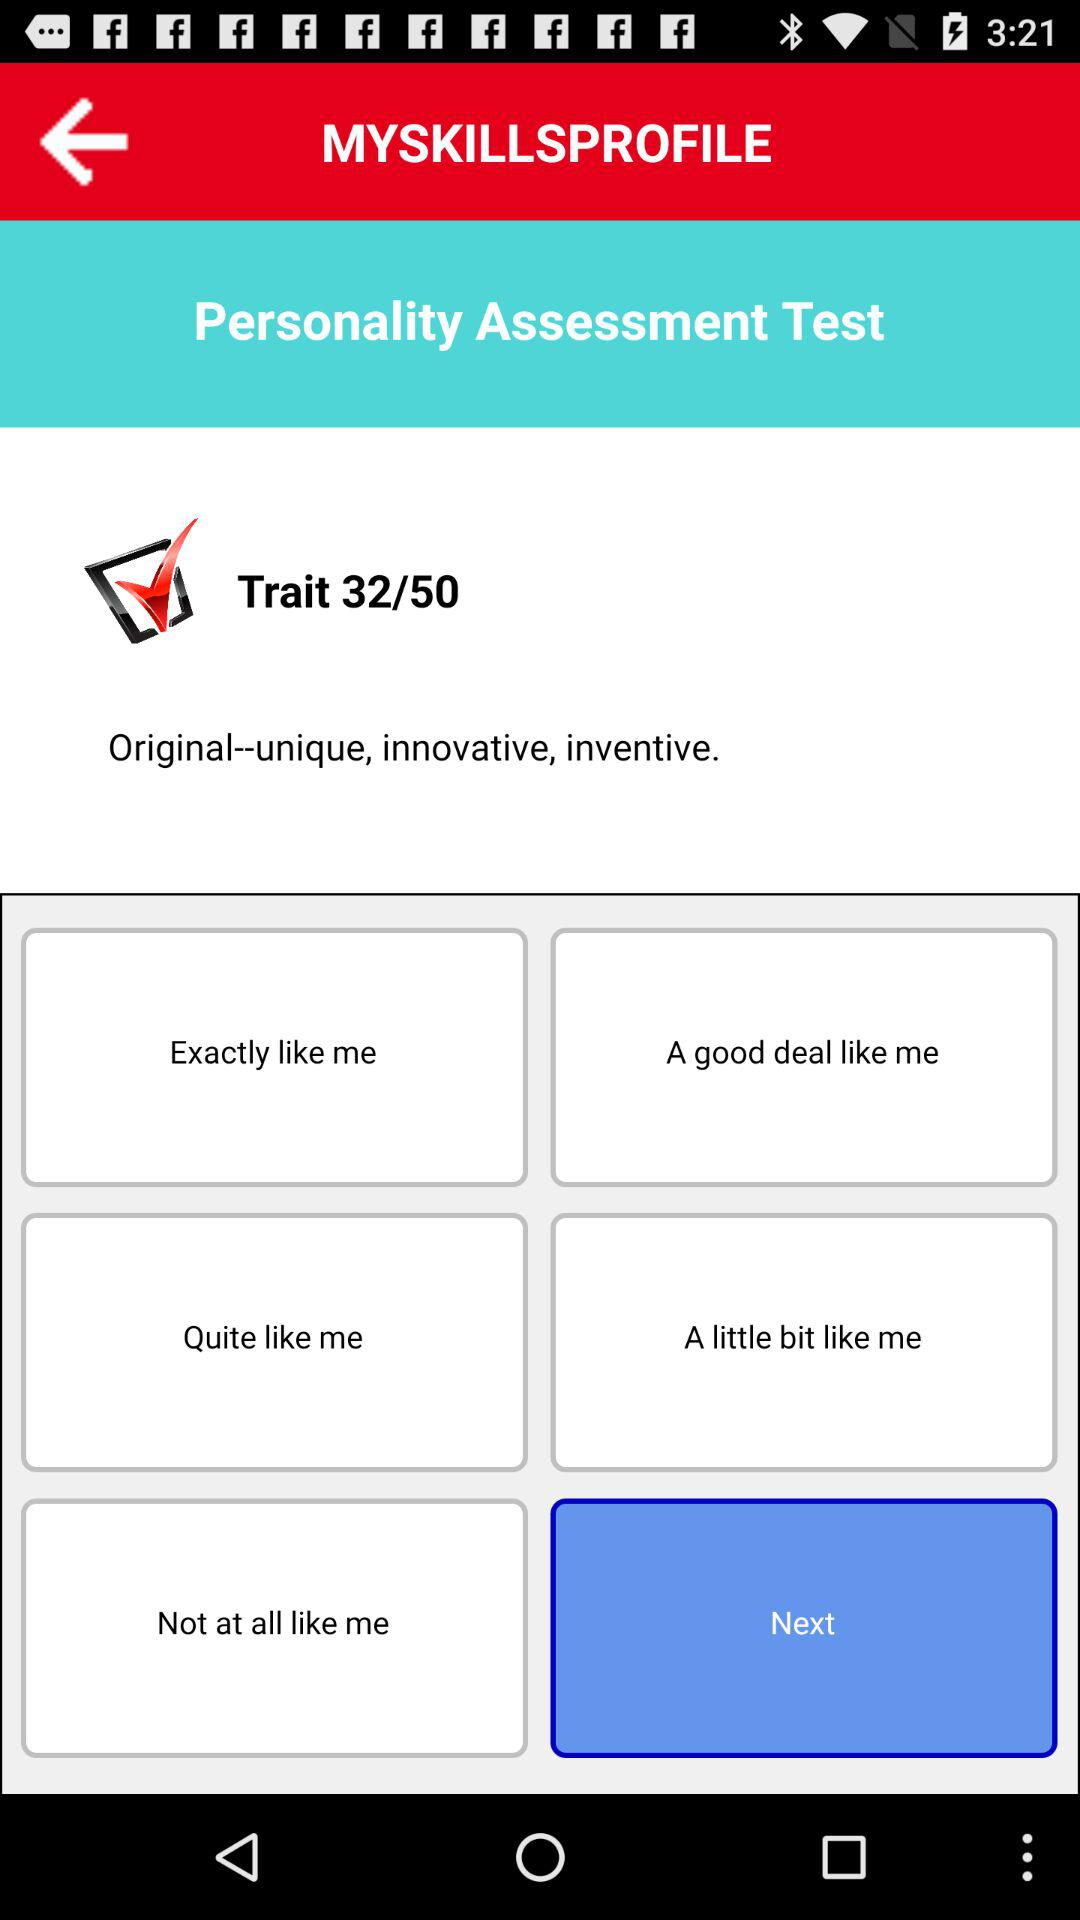Which option has been selected? The selected option is "Next". 